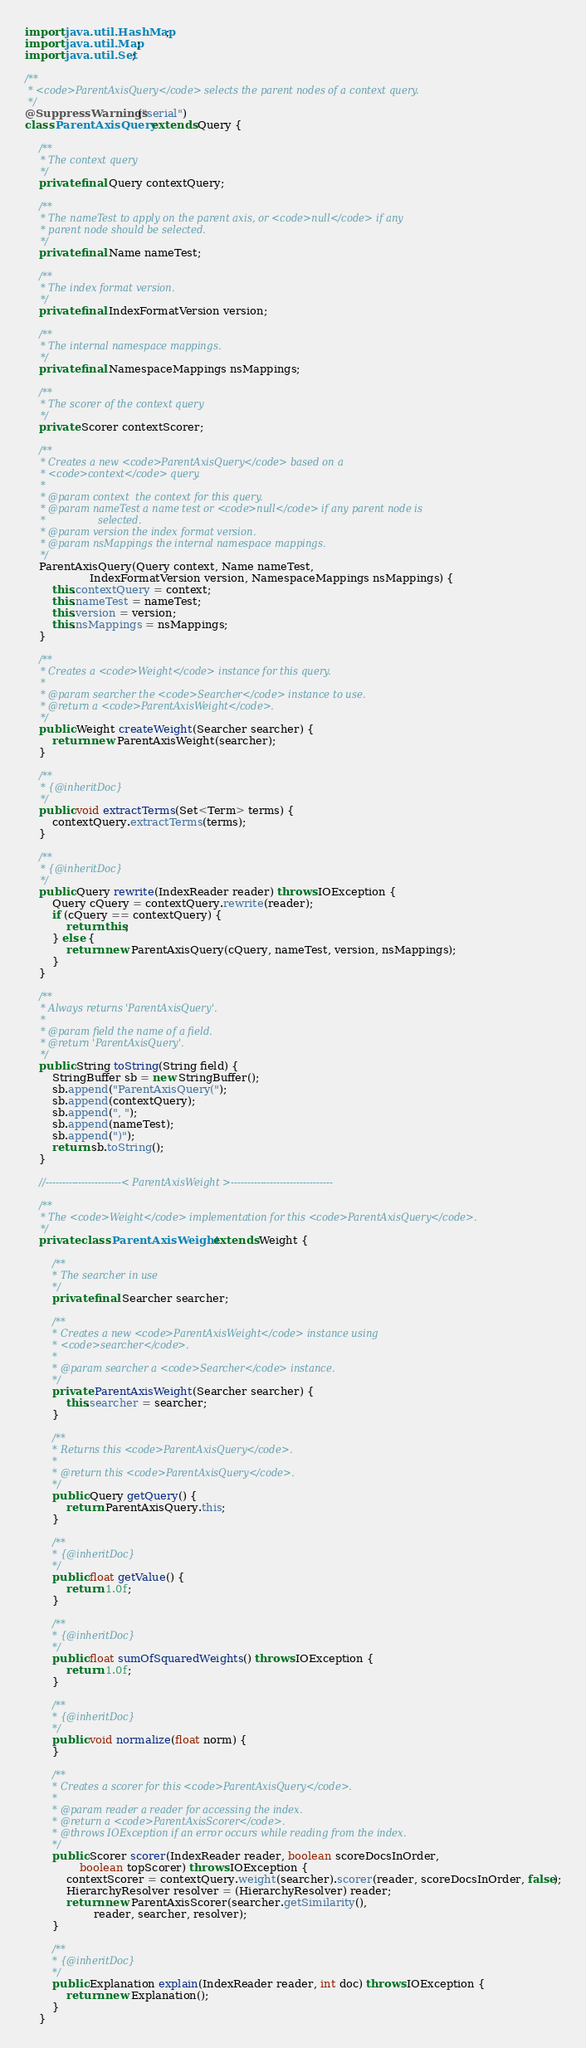<code> <loc_0><loc_0><loc_500><loc_500><_Java_>import java.util.HashMap;
import java.util.Map;
import java.util.Set;

/**
 * <code>ParentAxisQuery</code> selects the parent nodes of a context query.
 */
@SuppressWarnings("serial")
class ParentAxisQuery extends Query {

    /**
     * The context query
     */
    private final Query contextQuery;

    /**
     * The nameTest to apply on the parent axis, or <code>null</code> if any
     * parent node should be selected.
     */
    private final Name nameTest;

    /**
     * The index format version.
     */
    private final IndexFormatVersion version;

    /**
     * The internal namespace mappings.
     */
    private final NamespaceMappings nsMappings;

    /**
     * The scorer of the context query
     */
    private Scorer contextScorer;

    /**
     * Creates a new <code>ParentAxisQuery</code> based on a
     * <code>context</code> query.
     *
     * @param context  the context for this query.
     * @param nameTest a name test or <code>null</code> if any parent node is
     *                 selected.
     * @param version the index format version.
     * @param nsMappings the internal namespace mappings.
     */
    ParentAxisQuery(Query context, Name nameTest,
                   IndexFormatVersion version, NamespaceMappings nsMappings) {
        this.contextQuery = context;
        this.nameTest = nameTest;
        this.version = version;
        this.nsMappings = nsMappings;
    }

    /**
     * Creates a <code>Weight</code> instance for this query.
     *
     * @param searcher the <code>Searcher</code> instance to use.
     * @return a <code>ParentAxisWeight</code>.
     */
    public Weight createWeight(Searcher searcher) {
        return new ParentAxisWeight(searcher);
    }

    /**
     * {@inheritDoc}
     */
    public void extractTerms(Set<Term> terms) {
        contextQuery.extractTerms(terms);
    }

    /**
     * {@inheritDoc}
     */
    public Query rewrite(IndexReader reader) throws IOException {
        Query cQuery = contextQuery.rewrite(reader);
        if (cQuery == contextQuery) {
            return this;
        } else {
            return new ParentAxisQuery(cQuery, nameTest, version, nsMappings);
        }
    }

    /**
     * Always returns 'ParentAxisQuery'.
     *
     * @param field the name of a field.
     * @return 'ParentAxisQuery'.
     */
    public String toString(String field) {
        StringBuffer sb = new StringBuffer();
        sb.append("ParentAxisQuery(");
        sb.append(contextQuery);
        sb.append(", ");
        sb.append(nameTest);
        sb.append(")");
        return sb.toString();
    }

    //-----------------------< ParentAxisWeight >-------------------------------

    /**
     * The <code>Weight</code> implementation for this <code>ParentAxisQuery</code>.
     */
    private class ParentAxisWeight extends Weight {

        /**
         * The searcher in use
         */
        private final Searcher searcher;

        /**
         * Creates a new <code>ParentAxisWeight</code> instance using
         * <code>searcher</code>.
         *
         * @param searcher a <code>Searcher</code> instance.
         */
        private ParentAxisWeight(Searcher searcher) {
            this.searcher = searcher;
        }

        /**
         * Returns this <code>ParentAxisQuery</code>.
         *
         * @return this <code>ParentAxisQuery</code>.
         */
        public Query getQuery() {
            return ParentAxisQuery.this;
        }

        /**
         * {@inheritDoc}
         */
        public float getValue() {
            return 1.0f;
        }

        /**
         * {@inheritDoc}
         */
        public float sumOfSquaredWeights() throws IOException {
            return 1.0f;
        }

        /**
         * {@inheritDoc}
         */
        public void normalize(float norm) {
        }

        /**
         * Creates a scorer for this <code>ParentAxisQuery</code>.
         *
         * @param reader a reader for accessing the index.
         * @return a <code>ParentAxisScorer</code>.
         * @throws IOException if an error occurs while reading from the index.
         */
        public Scorer scorer(IndexReader reader, boolean scoreDocsInOrder,
                boolean topScorer) throws IOException {
            contextScorer = contextQuery.weight(searcher).scorer(reader, scoreDocsInOrder, false);
            HierarchyResolver resolver = (HierarchyResolver) reader;
            return new ParentAxisScorer(searcher.getSimilarity(),
                    reader, searcher, resolver);
        }

        /**
         * {@inheritDoc}
         */
        public Explanation explain(IndexReader reader, int doc) throws IOException {
            return new Explanation();
        }
    }
</code> 